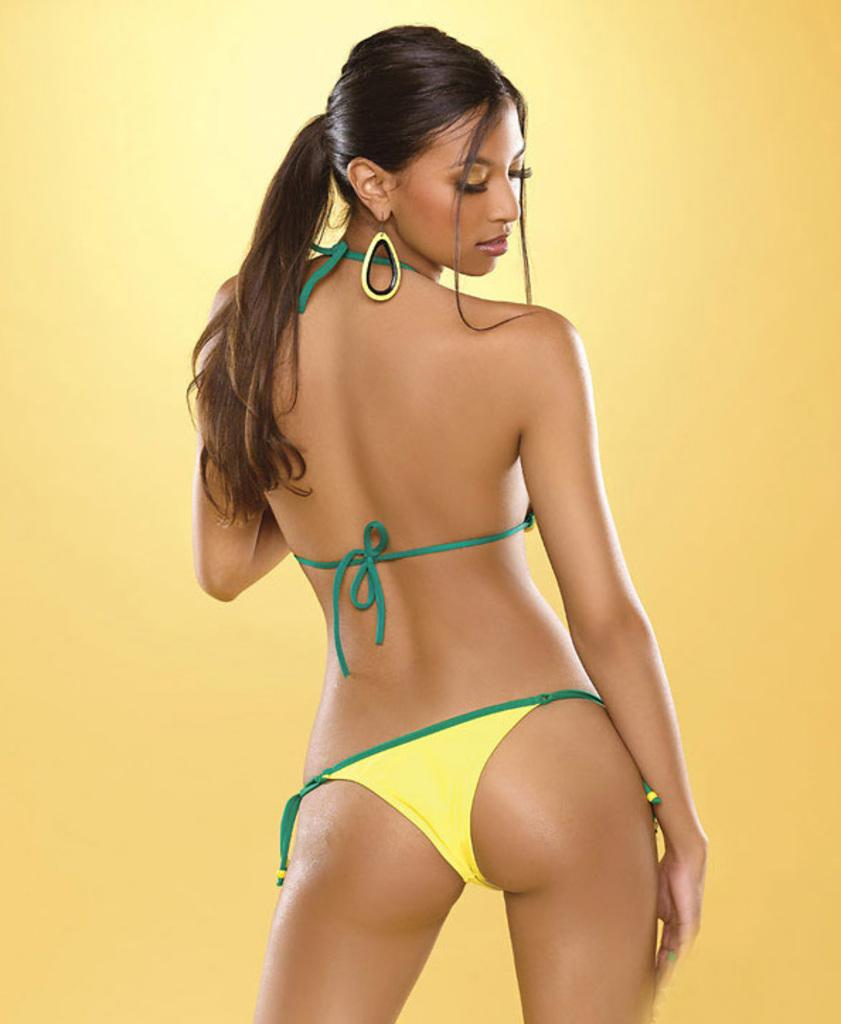What is the main subject in the image? There is a woman standing in the image. What can be seen in the background of the image? There is a wall in the image. What is the color of the wall? The wall is yellow in color. Can you tell me how many animals are in the zoo in the image? There is no zoo present in the image, so it is not possible to determine how many animals might be there. 